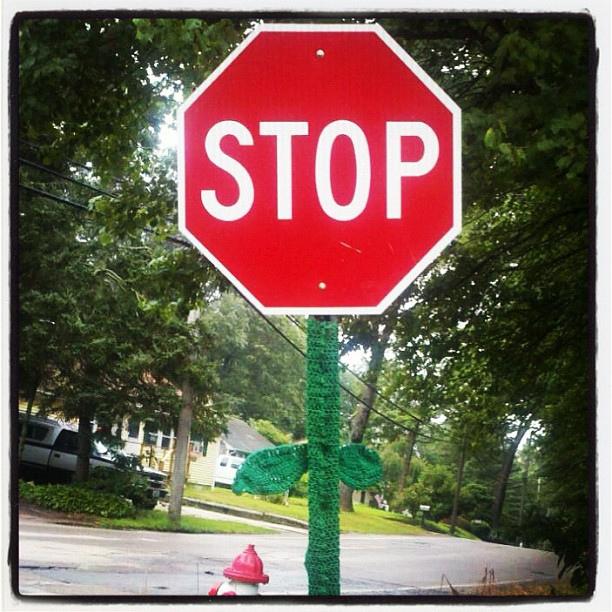Should one continue driving upon seeing this?
Concise answer only. No. What color is the pole?
Concise answer only. Green. What color is the signpost?
Be succinct. Green. What does the sign say?
Give a very brief answer. Stop. How many vehicles are in the background?
Quick response, please. 1. 